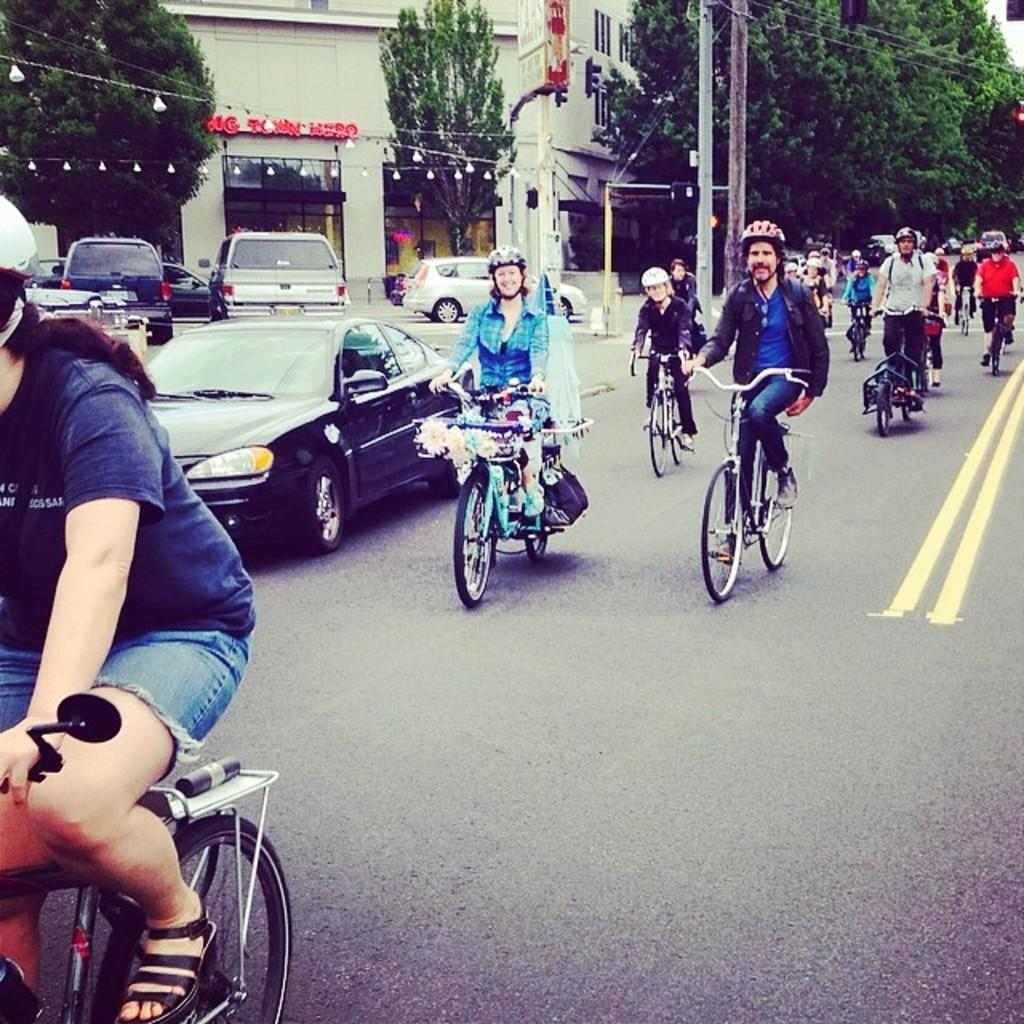What are the people in the image doing? The people in the image are riding bicycles. What else can be seen in the image besides the people on bicycles? There are cars, a building, trees, and poles in the image. What type of mint can be seen growing on the trees in the image? There is no mint visible in the image, as it only features trees and not any plants or herbs. 